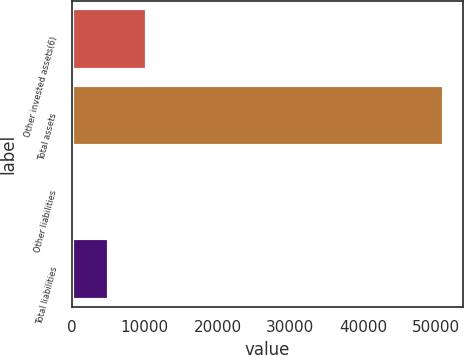<chart> <loc_0><loc_0><loc_500><loc_500><bar_chart><fcel>Other invested assets(6)<fcel>Total assets<fcel>Other liabilities<fcel>Total liabilities<nl><fcel>10246.2<fcel>51159<fcel>18<fcel>5132.1<nl></chart> 